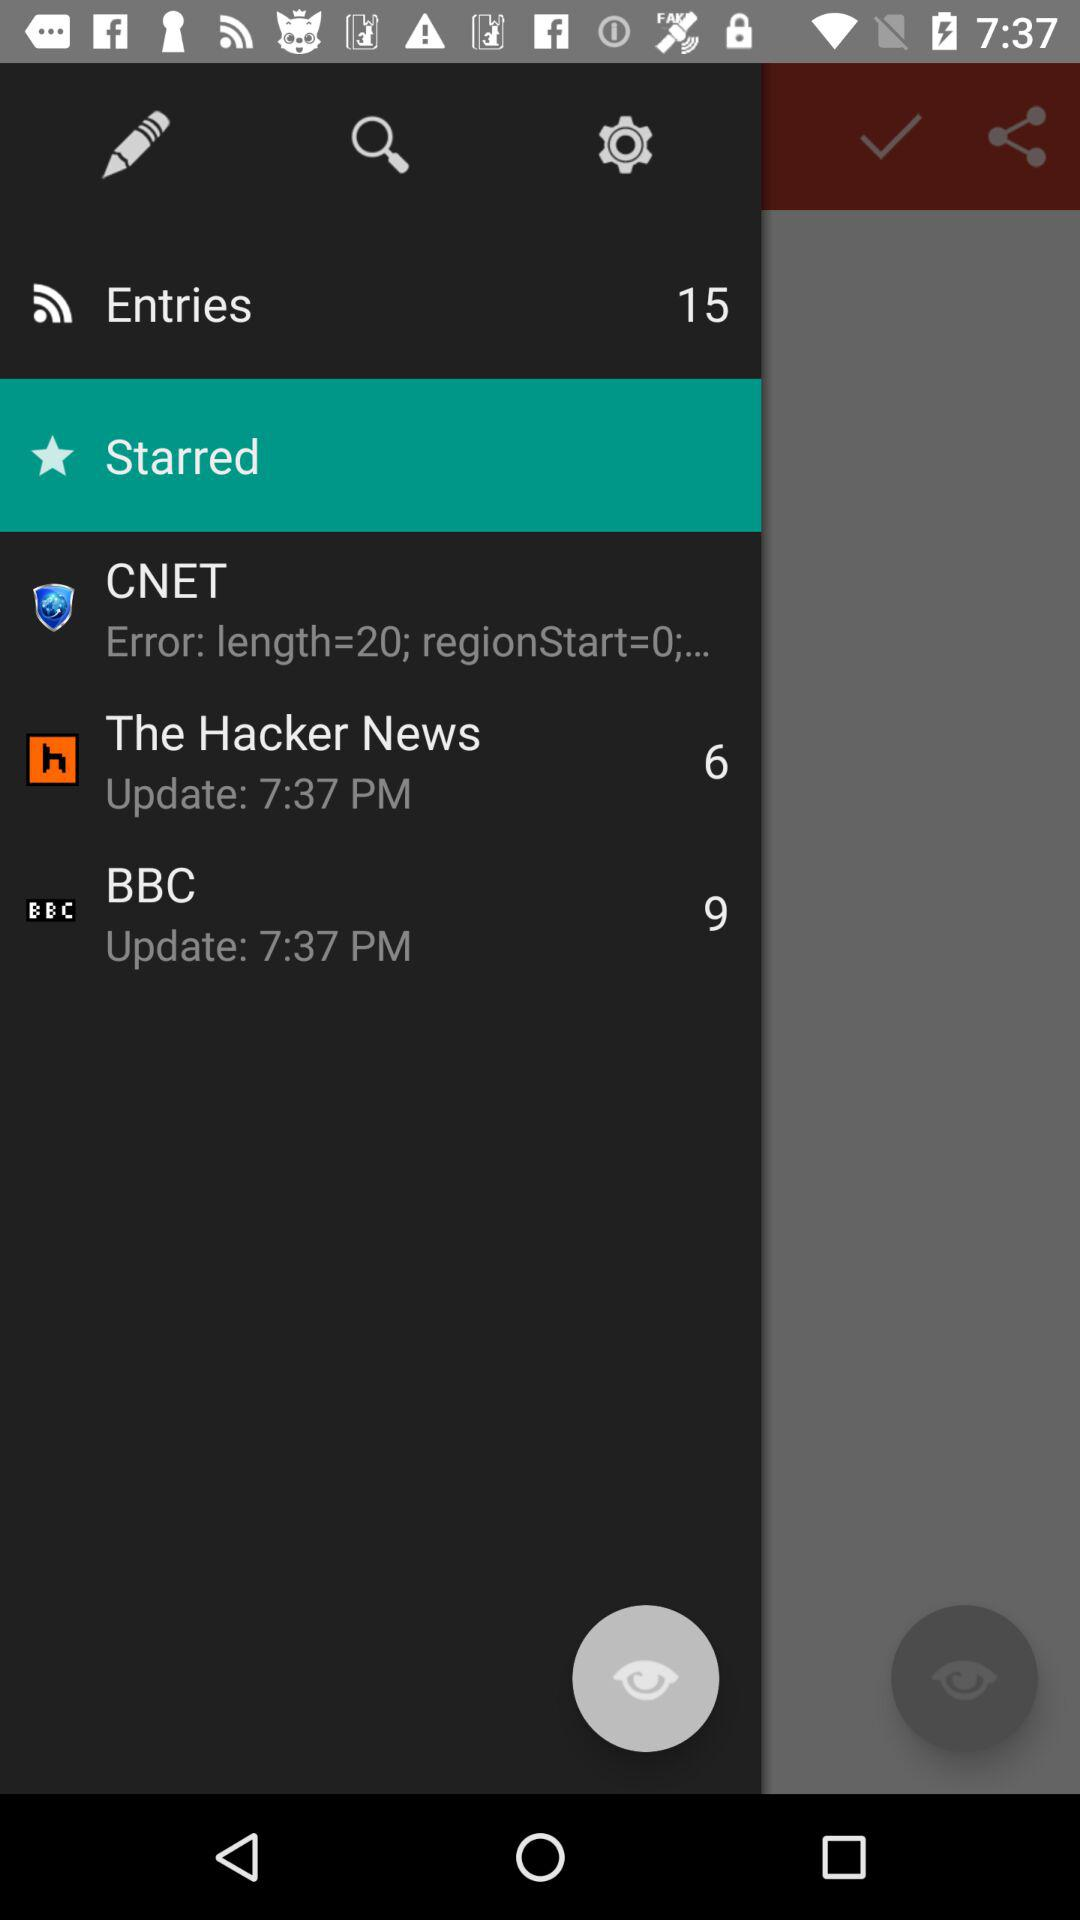How many entries are shown there? There are 15 entries shown. 